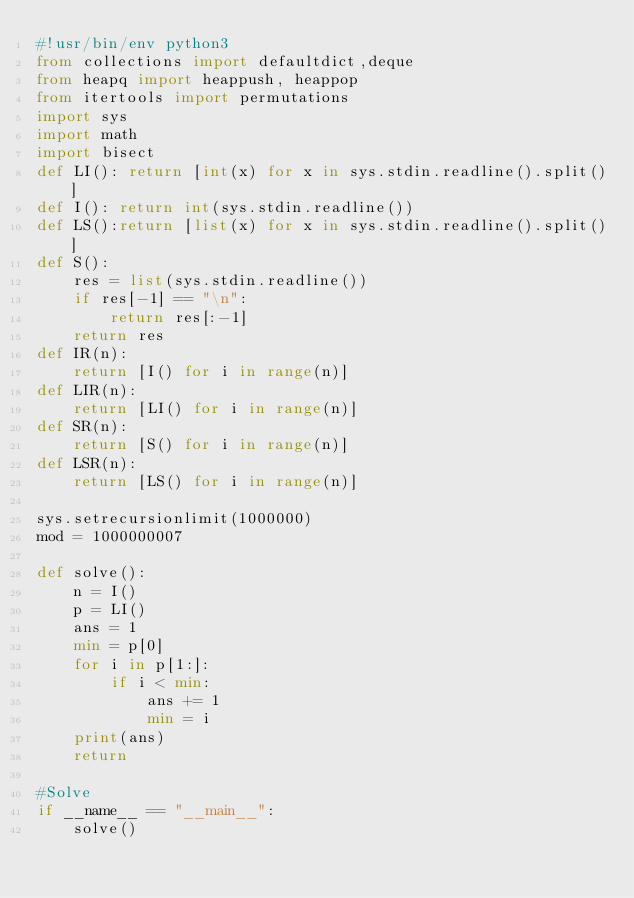<code> <loc_0><loc_0><loc_500><loc_500><_Python_>#!usr/bin/env python3
from collections import defaultdict,deque
from heapq import heappush, heappop
from itertools import permutations
import sys
import math
import bisect
def LI(): return [int(x) for x in sys.stdin.readline().split()]
def I(): return int(sys.stdin.readline())
def LS():return [list(x) for x in sys.stdin.readline().split()]
def S():
    res = list(sys.stdin.readline())
    if res[-1] == "\n":
        return res[:-1]
    return res
def IR(n):
    return [I() for i in range(n)]
def LIR(n):
    return [LI() for i in range(n)]
def SR(n):
    return [S() for i in range(n)]
def LSR(n):
    return [LS() for i in range(n)]

sys.setrecursionlimit(1000000)
mod = 1000000007

def solve():
    n = I()
    p = LI()
    ans = 1
    min = p[0]
    for i in p[1:]:
        if i < min:
            ans += 1
            min = i
    print(ans)
    return

#Solve
if __name__ == "__main__":
    solve()
</code> 